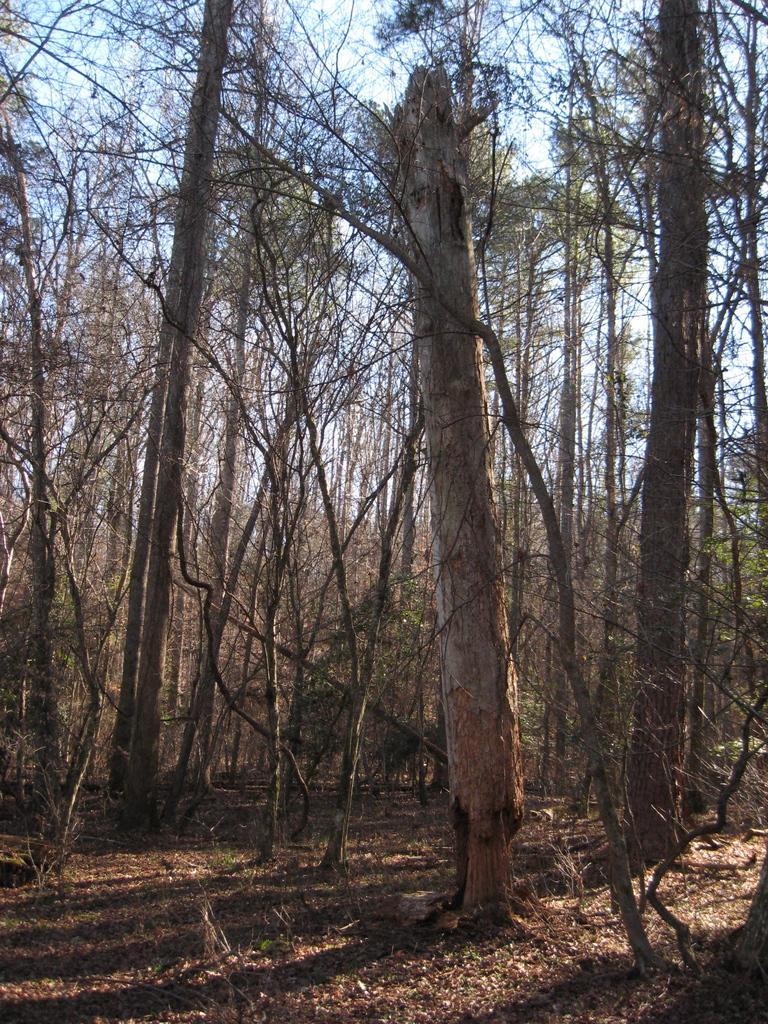Could you give a brief overview of what you see in this image? This is looking like a forest. In this image I can see many trees on the ground. At the top I can see the sky. 